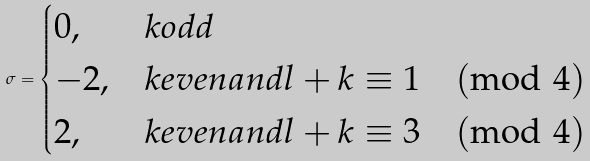Convert formula to latex. <formula><loc_0><loc_0><loc_500><loc_500>\sigma = \begin{cases} 0 , & k o d d \\ - 2 , & k e v e n a n d l + k \equiv 1 \pmod { 4 } \\ 2 , & k e v e n a n d l + k \equiv 3 \pmod { 4 } \\ \end{cases}</formula> 